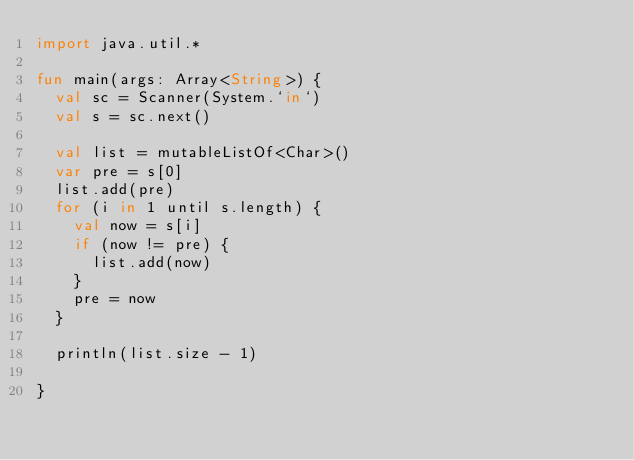<code> <loc_0><loc_0><loc_500><loc_500><_Kotlin_>import java.util.*

fun main(args: Array<String>) {
  val sc = Scanner(System.`in`)
  val s = sc.next()

  val list = mutableListOf<Char>()
  var pre = s[0]
  list.add(pre)
  for (i in 1 until s.length) {
    val now = s[i]
    if (now != pre) {
      list.add(now)
    }
    pre = now
  }

  println(list.size - 1)

}
</code> 